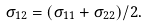Convert formula to latex. <formula><loc_0><loc_0><loc_500><loc_500>\sigma _ { 1 2 } = ( \sigma _ { 1 1 } + \sigma _ { 2 2 } ) / 2 .</formula> 